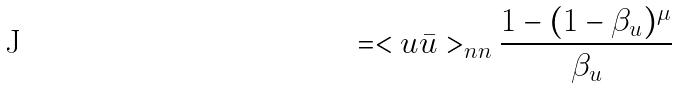Convert formula to latex. <formula><loc_0><loc_0><loc_500><loc_500>= < u \bar { u } > _ { n n } \frac { 1 - ( 1 - \beta _ { u } ) ^ { \mu } } { \beta _ { u } }</formula> 